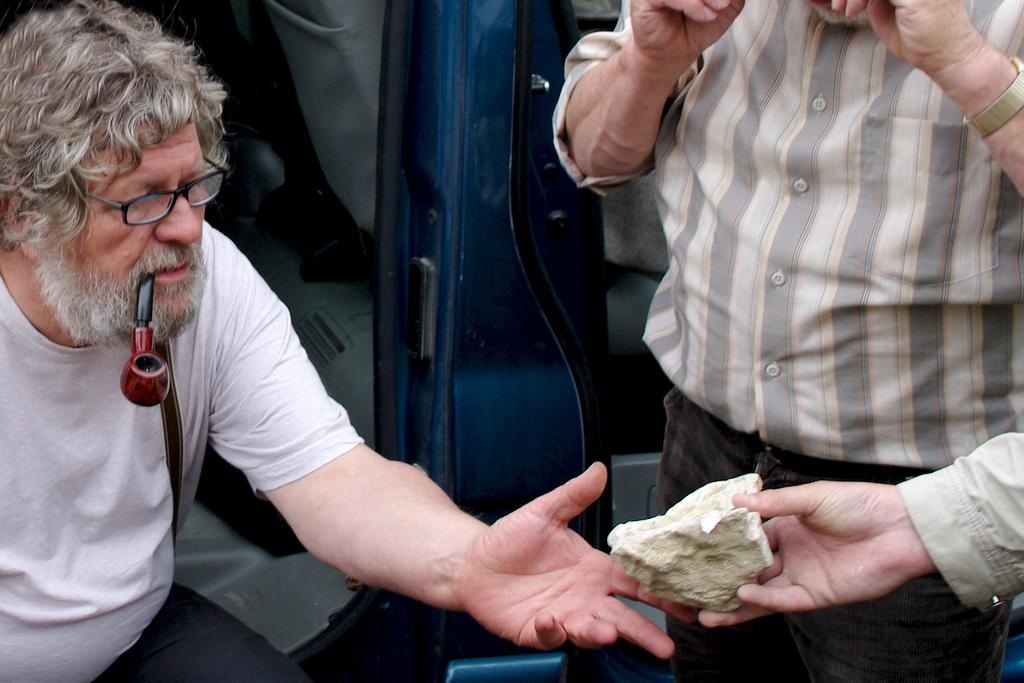What is the person in the image wearing on their face? The person in the image is wearing specs. What is the person with specs holding in their mouth? The person with specs has a pipe in their mouth. How many people are visible in the image? There are two people visible in the image. What is a person's hand holding in the image? A person's hand is holding a stone in the image. What type of crown is the person wearing in the image? There is no crown visible in the image; the person is wearing specs. What is the person rubbing on their arm in the image? There is no person rubbing anything on their arm in the image. 